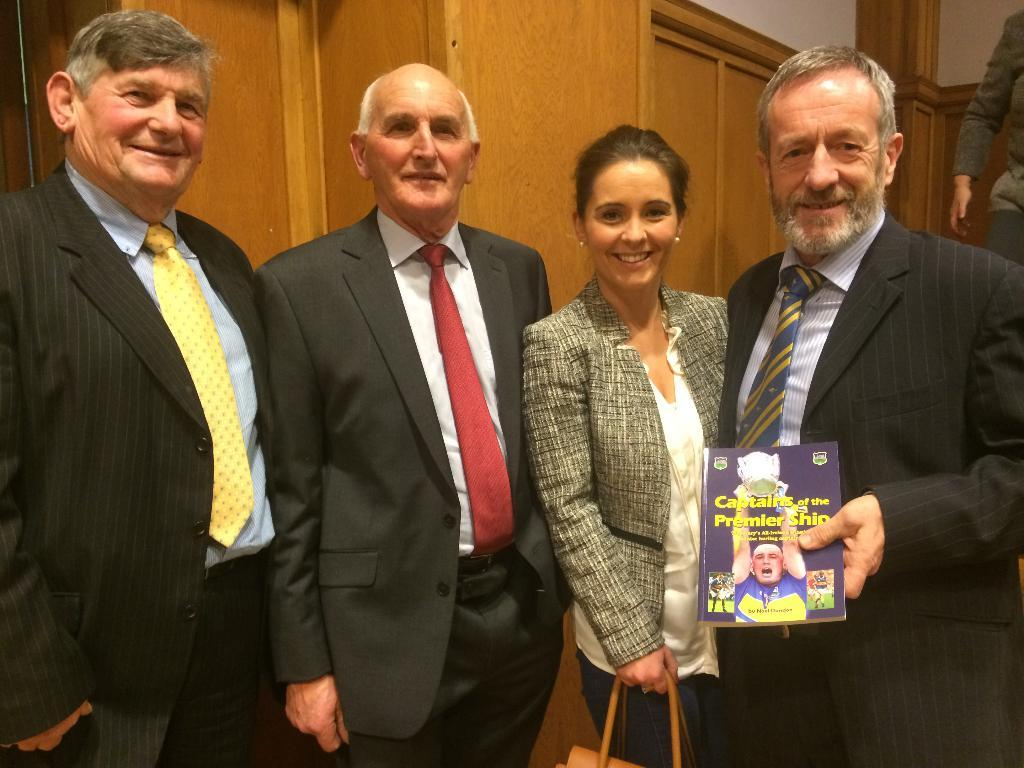What are the people in the room doing? There are people standing in the room. Can you describe what one person is holding? One person is holding a book. What is another person holding? One person is holding a handbag. What can be seen in the background of the room? There is a wooden wall in the background. What word is being said by the person holding the book in the image? There is no indication in the image that the person holding the book is saying any word. Can you describe the bubble floating near the person holding the handbag? There is no bubble present in the image. 